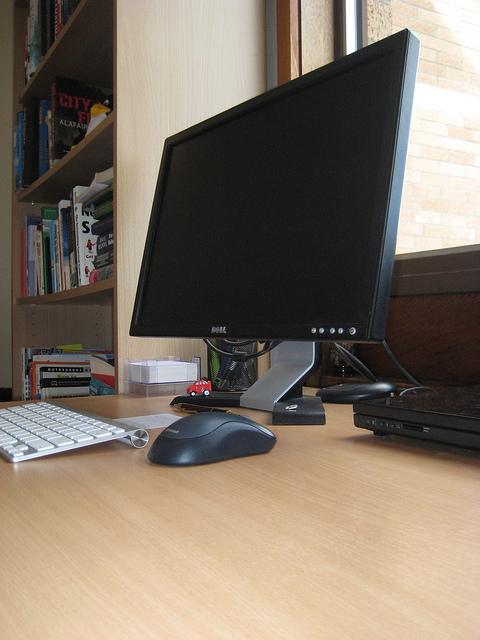What size is the monitor?
Quick response, please. Big. What hand do you presume the owner would write with?
Quick response, please. Right. Where is the word city?
Be succinct. Book. 